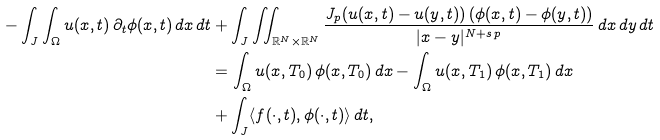Convert formula to latex. <formula><loc_0><loc_0><loc_500><loc_500>- \int _ { J } \int _ { \Omega } u ( x , t ) \, \partial _ { t } \phi ( x , t ) \, d x \, d t & + \int _ { J } \iint _ { \mathbb { R } ^ { N } \times \mathbb { R } ^ { N } } \frac { J _ { p } ( u ( x , t ) - u ( y , t ) ) \, ( \phi ( x , t ) - \phi ( y , t ) ) } { | x - y | ^ { N + s \, p } } \, d x \, d y \, d t \\ & = \int _ { \Omega } u ( x , T _ { 0 } ) \, \phi ( x , T _ { 0 } ) \, d x - \int _ { \Omega } u ( x , T _ { 1 } ) \, \phi ( x , T _ { 1 } ) \, d x \\ & + \int _ { J } \langle f ( \cdot , t ) , \phi ( \cdot , t ) \rangle \, d t ,</formula> 